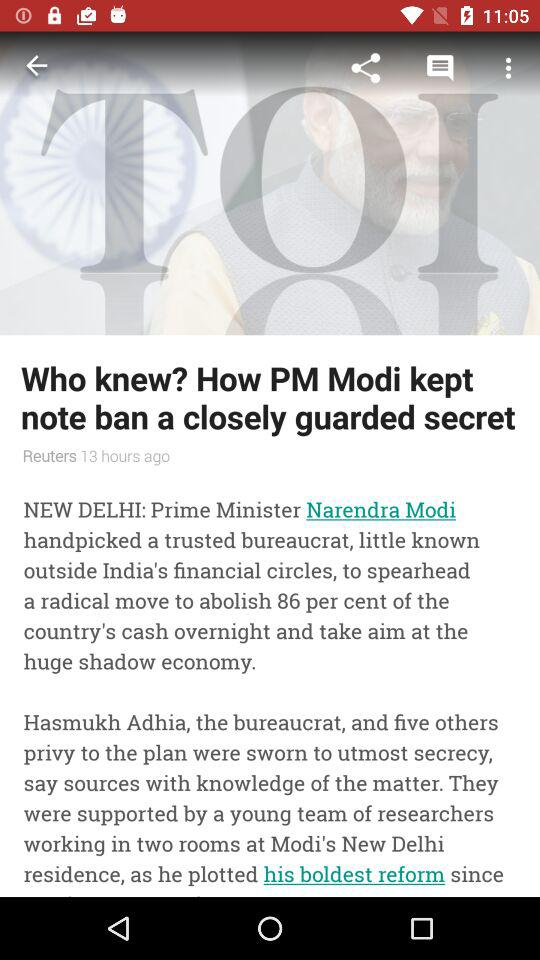How many people did Modi handpick?
Answer the question using a single word or phrase. 6 